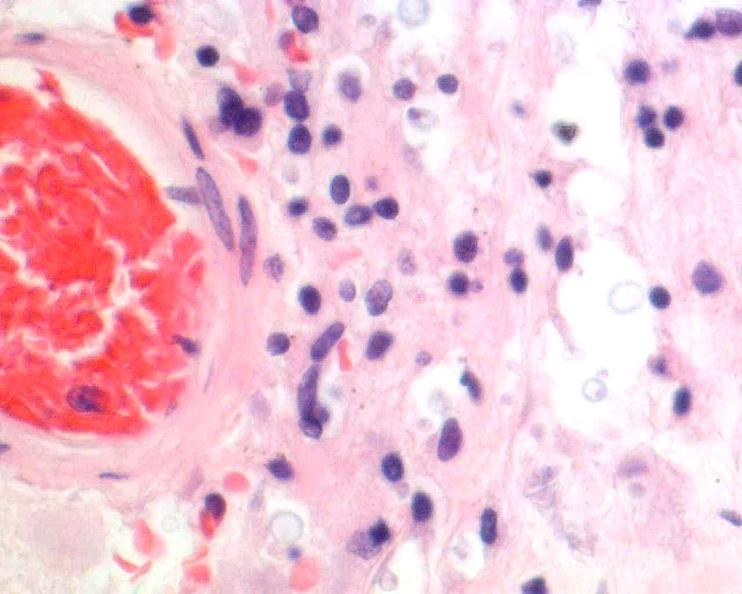s color present?
Answer the question using a single word or phrase. No 